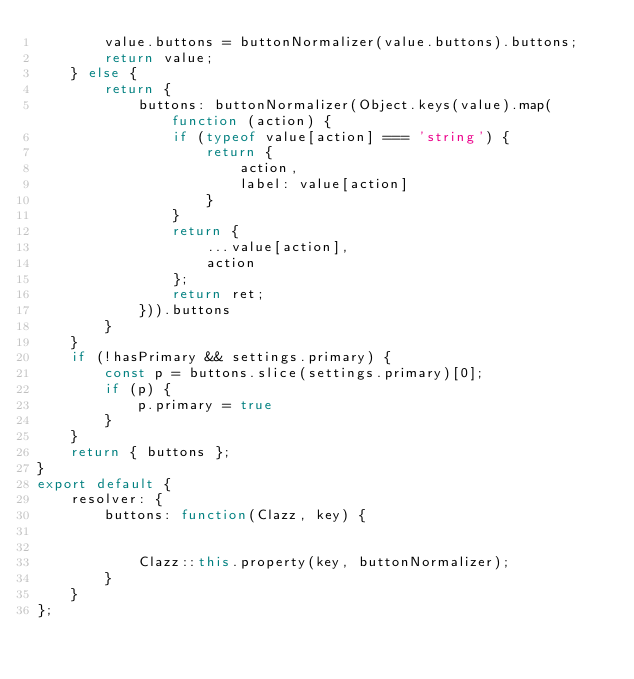Convert code to text. <code><loc_0><loc_0><loc_500><loc_500><_JavaScript_>        value.buttons = buttonNormalizer(value.buttons).buttons;
        return value;
    } else {
        return {
            buttons: buttonNormalizer(Object.keys(value).map(function (action) {
                if (typeof value[action] === 'string') {
                    return {
                        action,
                        label: value[action]
                    }
                }
                return {
                    ...value[action],
                    action
                };
                return ret;
            })).buttons
        }
    }
    if (!hasPrimary && settings.primary) {
        const p = buttons.slice(settings.primary)[0];
        if (p) {
            p.primary = true
        }
    }
    return { buttons };
}
export default {
    resolver: {
        buttons: function(Clazz, key) {


            Clazz::this.property(key, buttonNormalizer);
        }
    }
};
</code> 